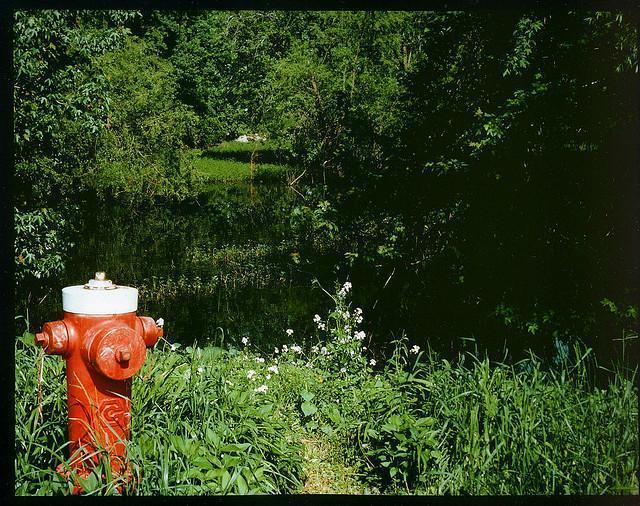How many plugs does the hydrant have?
Give a very brief answer. 3. 